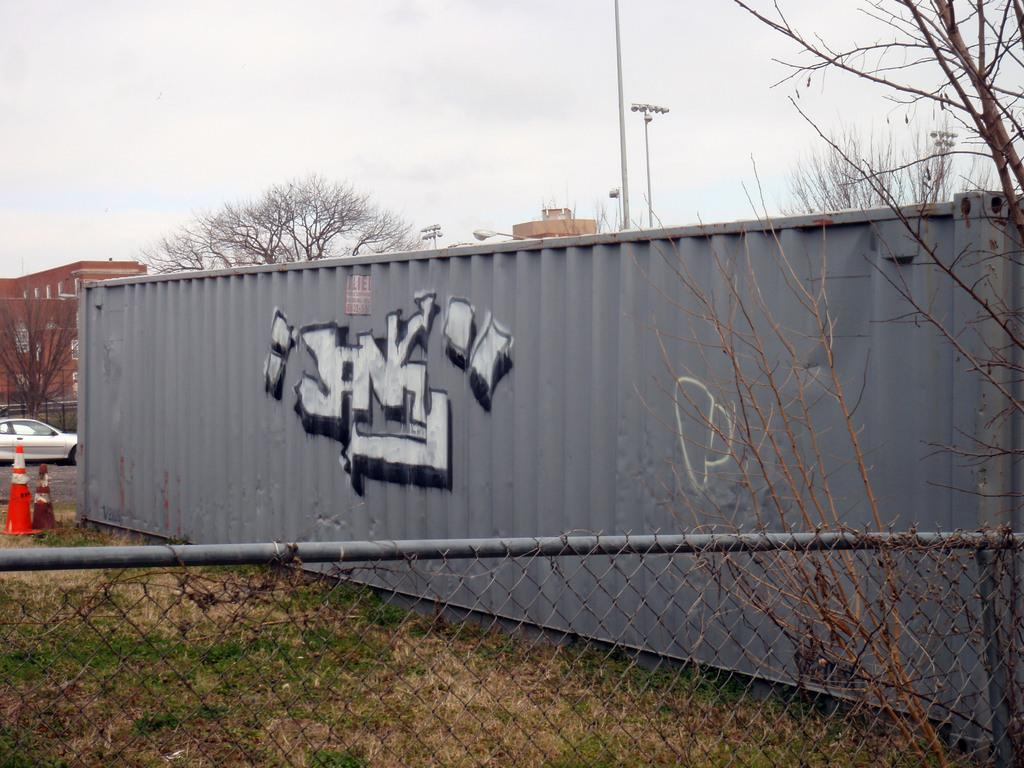<image>
Create a compact narrative representing the image presented. Gray container with graffiti that says "JNY" on it. 